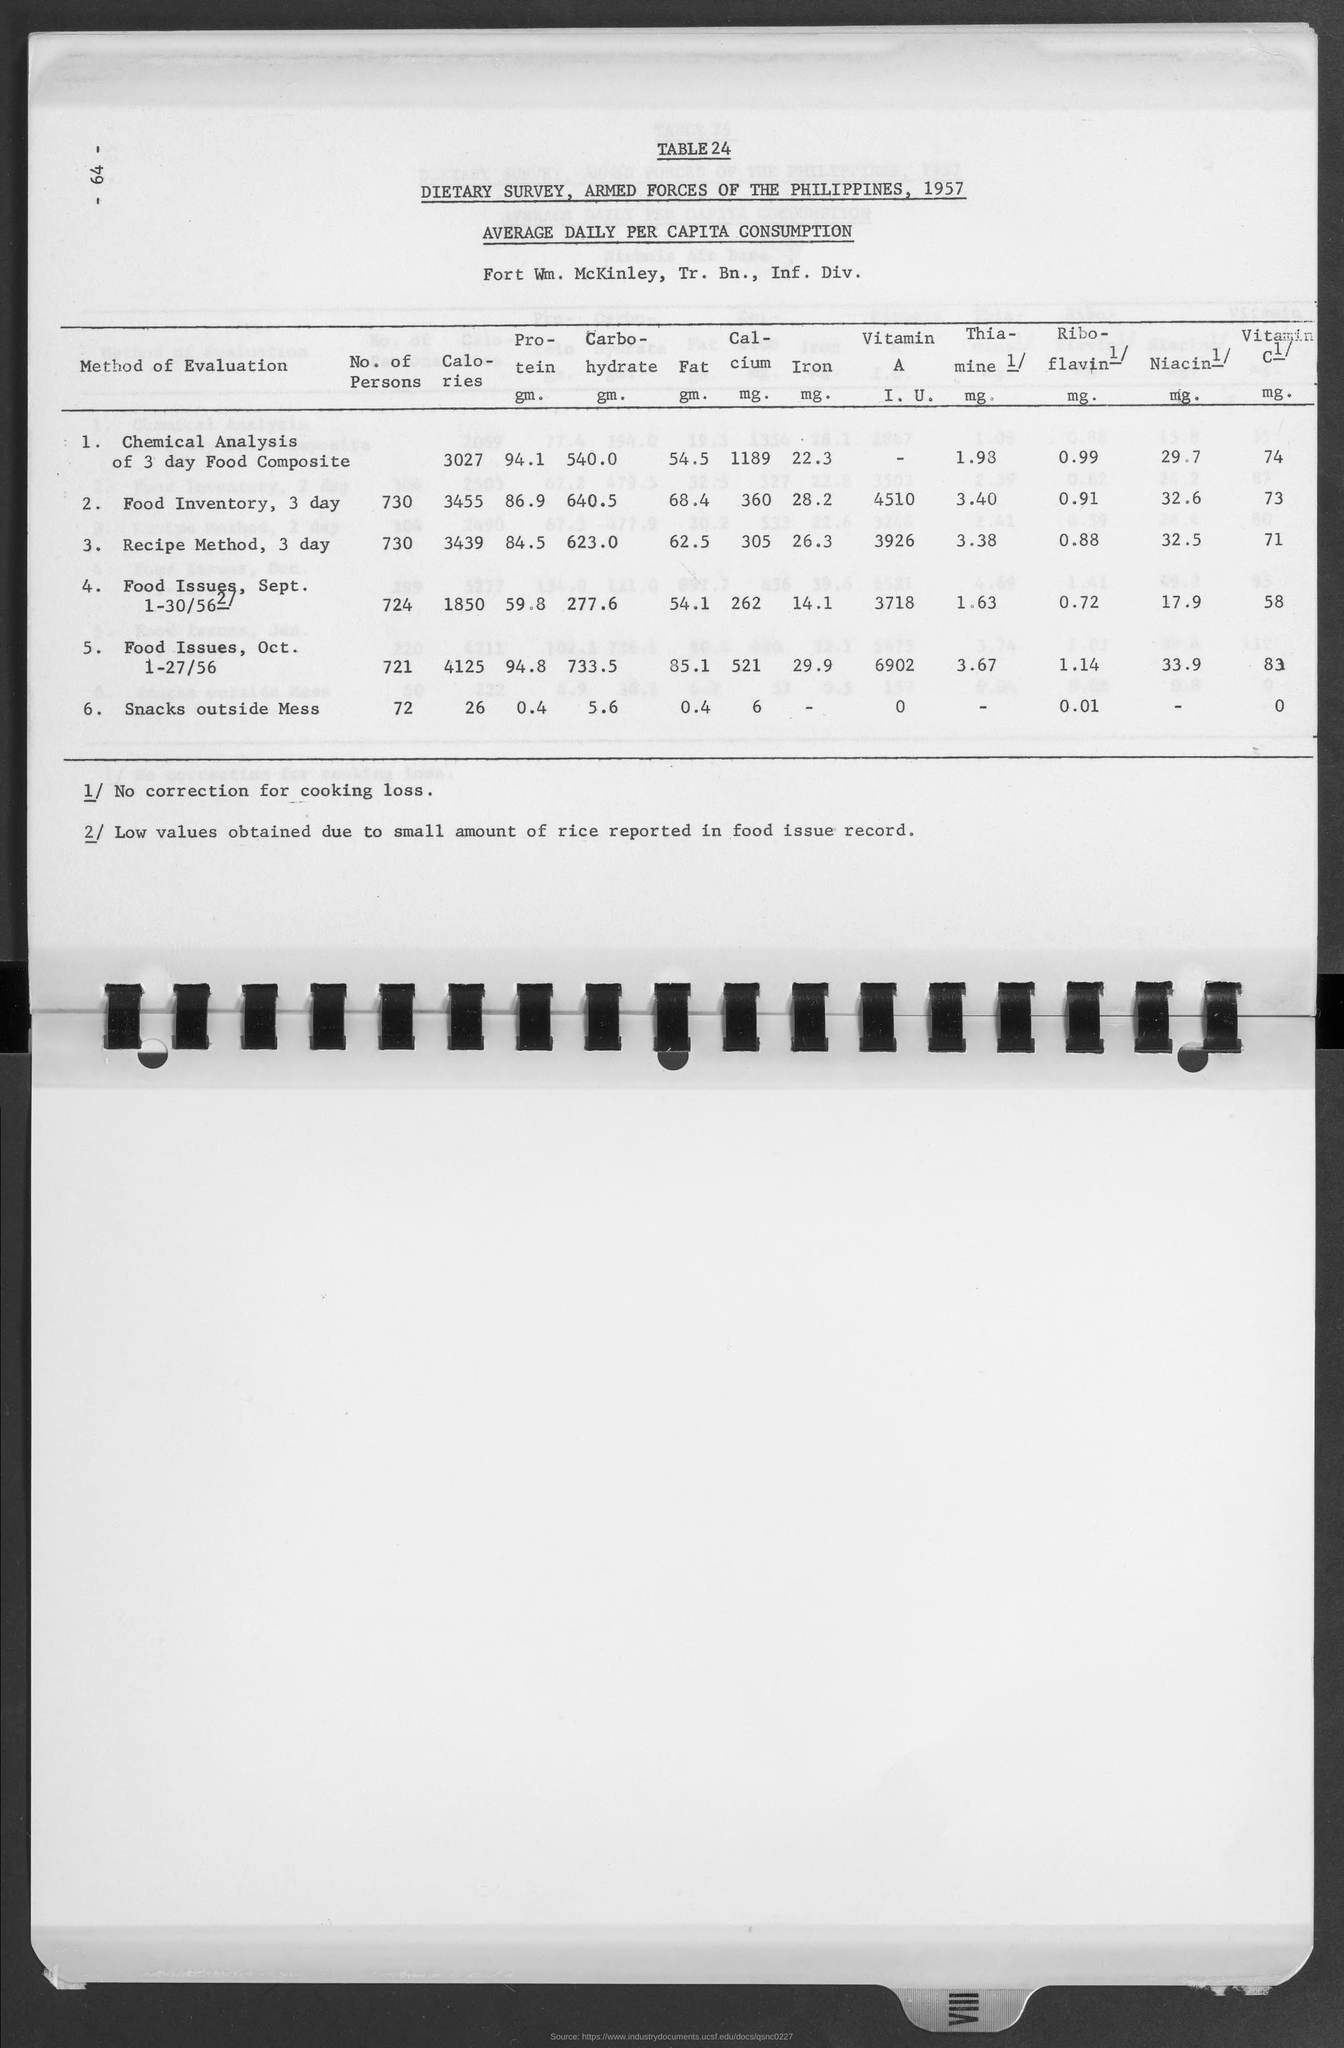What is the table no. ?
Your answer should be very brief. Table24. What is the amount of calories  for chemical analysis of 3 day food composite?
Provide a short and direct response. 3027. What is the amount of calories  for food inventory, 3 day?
Ensure brevity in your answer.  3455. What is the amount of calories  for recipe method, 3 day?
Your response must be concise. 3439. What is the amount of calories  for food issues, sept. 1-30/56?
Ensure brevity in your answer.  1850. What is the amount of calories  for food issues, 1-27/56 ?
Give a very brief answer. 4125. What is the amount of calories  for  snacks outside mess ?
Give a very brief answer. 26. What is the number at top-left corner of the page ?
Provide a succinct answer. - 64 -. What is the amount of protein gm. for chemical analysis of 3 day food composite?
Your response must be concise. 94.1. What is the amount of carbohydrate gm. for chemical analysis of 3 day food composite?
Provide a short and direct response. 540.0 gm. 